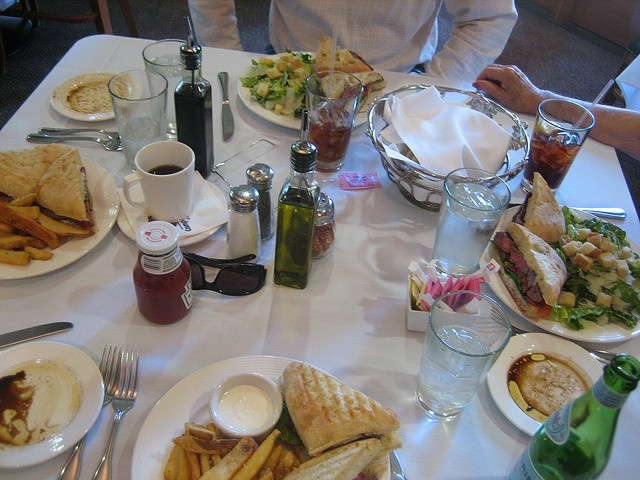Describe the objects in this image and their specific colors. I can see dining table in darkblue, darkgray, and gray tones, people in darkblue and gray tones, bowl in darkblue, darkgray, and lavender tones, cup in darkblue, darkgray, and gray tones, and bowl in darkblue, darkgray, tan, gray, and lightblue tones in this image. 